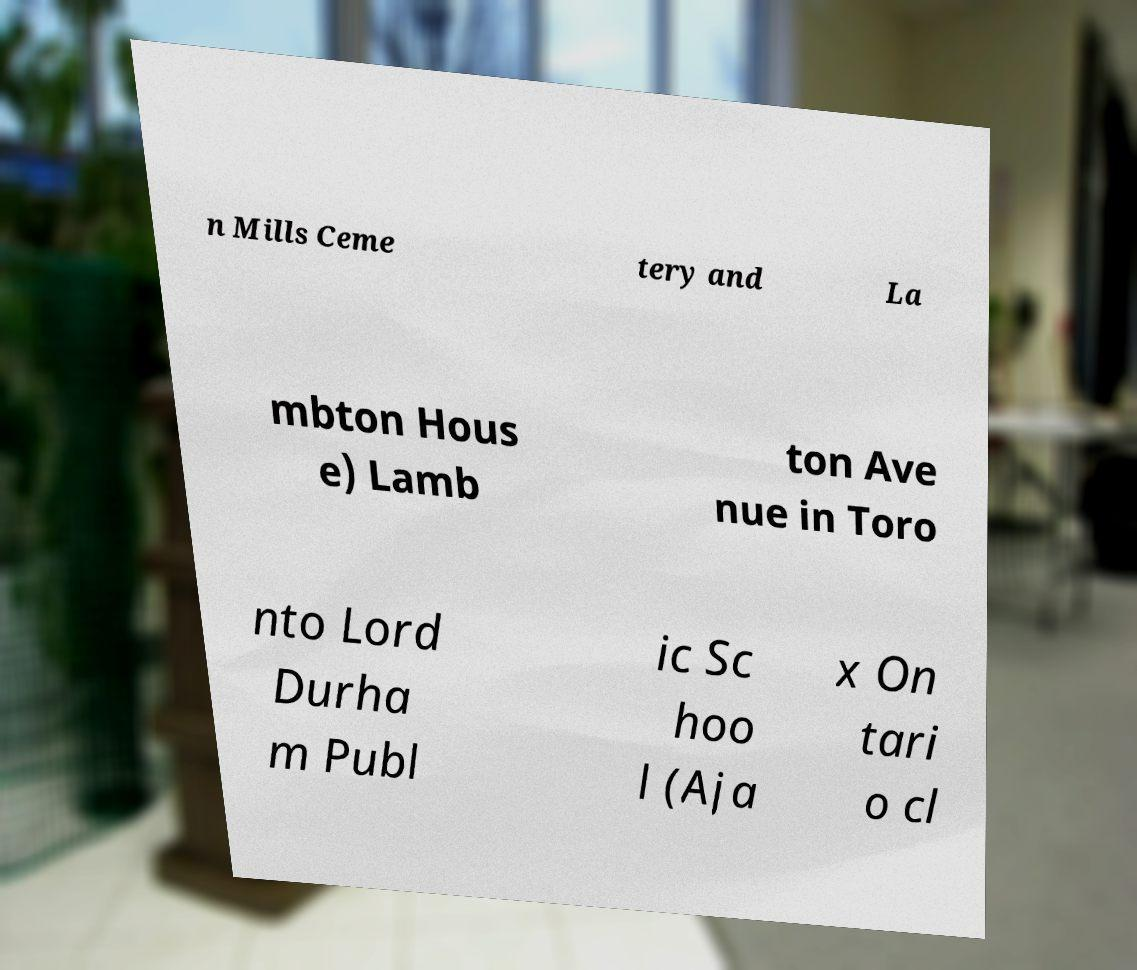Could you assist in decoding the text presented in this image and type it out clearly? n Mills Ceme tery and La mbton Hous e) Lamb ton Ave nue in Toro nto Lord Durha m Publ ic Sc hoo l (Aja x On tari o cl 